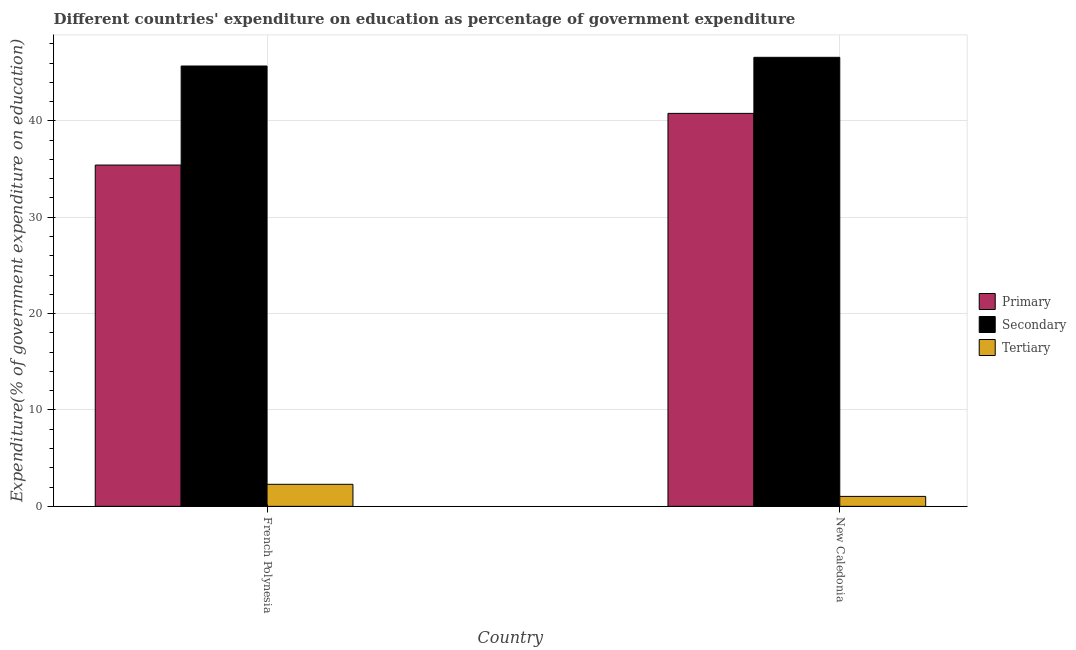How many bars are there on the 2nd tick from the right?
Offer a very short reply. 3. What is the label of the 1st group of bars from the left?
Provide a succinct answer. French Polynesia. In how many cases, is the number of bars for a given country not equal to the number of legend labels?
Make the answer very short. 0. What is the expenditure on secondary education in French Polynesia?
Offer a terse response. 45.69. Across all countries, what is the maximum expenditure on secondary education?
Provide a short and direct response. 46.59. Across all countries, what is the minimum expenditure on tertiary education?
Your answer should be compact. 1.03. In which country was the expenditure on primary education maximum?
Make the answer very short. New Caledonia. In which country was the expenditure on tertiary education minimum?
Your response must be concise. New Caledonia. What is the total expenditure on primary education in the graph?
Make the answer very short. 76.19. What is the difference between the expenditure on tertiary education in French Polynesia and that in New Caledonia?
Your response must be concise. 1.26. What is the difference between the expenditure on primary education in French Polynesia and the expenditure on secondary education in New Caledonia?
Your answer should be very brief. -11.18. What is the average expenditure on tertiary education per country?
Keep it short and to the point. 1.66. What is the difference between the expenditure on secondary education and expenditure on primary education in French Polynesia?
Provide a short and direct response. 10.28. What is the ratio of the expenditure on primary education in French Polynesia to that in New Caledonia?
Keep it short and to the point. 0.87. Is the expenditure on primary education in French Polynesia less than that in New Caledonia?
Keep it short and to the point. Yes. In how many countries, is the expenditure on secondary education greater than the average expenditure on secondary education taken over all countries?
Provide a short and direct response. 1. What does the 1st bar from the left in French Polynesia represents?
Ensure brevity in your answer.  Primary. What does the 1st bar from the right in New Caledonia represents?
Keep it short and to the point. Tertiary. Are all the bars in the graph horizontal?
Your answer should be compact. No. How many countries are there in the graph?
Give a very brief answer. 2. What is the difference between two consecutive major ticks on the Y-axis?
Make the answer very short. 10. Are the values on the major ticks of Y-axis written in scientific E-notation?
Ensure brevity in your answer.  No. Does the graph contain grids?
Provide a short and direct response. Yes. Where does the legend appear in the graph?
Your response must be concise. Center right. What is the title of the graph?
Ensure brevity in your answer.  Different countries' expenditure on education as percentage of government expenditure. Does "Other sectors" appear as one of the legend labels in the graph?
Your answer should be very brief. No. What is the label or title of the Y-axis?
Keep it short and to the point. Expenditure(% of government expenditure on education). What is the Expenditure(% of government expenditure on education) of Primary in French Polynesia?
Provide a short and direct response. 35.41. What is the Expenditure(% of government expenditure on education) of Secondary in French Polynesia?
Your response must be concise. 45.69. What is the Expenditure(% of government expenditure on education) of Tertiary in French Polynesia?
Provide a succinct answer. 2.29. What is the Expenditure(% of government expenditure on education) in Primary in New Caledonia?
Provide a short and direct response. 40.77. What is the Expenditure(% of government expenditure on education) in Secondary in New Caledonia?
Your answer should be very brief. 46.59. What is the Expenditure(% of government expenditure on education) in Tertiary in New Caledonia?
Offer a terse response. 1.03. Across all countries, what is the maximum Expenditure(% of government expenditure on education) in Primary?
Provide a succinct answer. 40.77. Across all countries, what is the maximum Expenditure(% of government expenditure on education) in Secondary?
Offer a terse response. 46.59. Across all countries, what is the maximum Expenditure(% of government expenditure on education) of Tertiary?
Keep it short and to the point. 2.29. Across all countries, what is the minimum Expenditure(% of government expenditure on education) in Primary?
Ensure brevity in your answer.  35.41. Across all countries, what is the minimum Expenditure(% of government expenditure on education) of Secondary?
Offer a terse response. 45.69. Across all countries, what is the minimum Expenditure(% of government expenditure on education) in Tertiary?
Make the answer very short. 1.03. What is the total Expenditure(% of government expenditure on education) of Primary in the graph?
Provide a short and direct response. 76.19. What is the total Expenditure(% of government expenditure on education) of Secondary in the graph?
Your answer should be very brief. 92.28. What is the total Expenditure(% of government expenditure on education) of Tertiary in the graph?
Provide a short and direct response. 3.32. What is the difference between the Expenditure(% of government expenditure on education) in Primary in French Polynesia and that in New Caledonia?
Ensure brevity in your answer.  -5.36. What is the difference between the Expenditure(% of government expenditure on education) of Secondary in French Polynesia and that in New Caledonia?
Give a very brief answer. -0.9. What is the difference between the Expenditure(% of government expenditure on education) of Tertiary in French Polynesia and that in New Caledonia?
Make the answer very short. 1.26. What is the difference between the Expenditure(% of government expenditure on education) in Primary in French Polynesia and the Expenditure(% of government expenditure on education) in Secondary in New Caledonia?
Make the answer very short. -11.18. What is the difference between the Expenditure(% of government expenditure on education) in Primary in French Polynesia and the Expenditure(% of government expenditure on education) in Tertiary in New Caledonia?
Make the answer very short. 34.38. What is the difference between the Expenditure(% of government expenditure on education) in Secondary in French Polynesia and the Expenditure(% of government expenditure on education) in Tertiary in New Caledonia?
Ensure brevity in your answer.  44.66. What is the average Expenditure(% of government expenditure on education) in Primary per country?
Keep it short and to the point. 38.09. What is the average Expenditure(% of government expenditure on education) in Secondary per country?
Offer a terse response. 46.14. What is the average Expenditure(% of government expenditure on education) of Tertiary per country?
Offer a very short reply. 1.66. What is the difference between the Expenditure(% of government expenditure on education) of Primary and Expenditure(% of government expenditure on education) of Secondary in French Polynesia?
Ensure brevity in your answer.  -10.28. What is the difference between the Expenditure(% of government expenditure on education) in Primary and Expenditure(% of government expenditure on education) in Tertiary in French Polynesia?
Provide a succinct answer. 33.13. What is the difference between the Expenditure(% of government expenditure on education) in Secondary and Expenditure(% of government expenditure on education) in Tertiary in French Polynesia?
Give a very brief answer. 43.4. What is the difference between the Expenditure(% of government expenditure on education) in Primary and Expenditure(% of government expenditure on education) in Secondary in New Caledonia?
Your response must be concise. -5.82. What is the difference between the Expenditure(% of government expenditure on education) in Primary and Expenditure(% of government expenditure on education) in Tertiary in New Caledonia?
Your answer should be compact. 39.74. What is the difference between the Expenditure(% of government expenditure on education) in Secondary and Expenditure(% of government expenditure on education) in Tertiary in New Caledonia?
Give a very brief answer. 45.56. What is the ratio of the Expenditure(% of government expenditure on education) of Primary in French Polynesia to that in New Caledonia?
Your answer should be compact. 0.87. What is the ratio of the Expenditure(% of government expenditure on education) of Secondary in French Polynesia to that in New Caledonia?
Your response must be concise. 0.98. What is the ratio of the Expenditure(% of government expenditure on education) in Tertiary in French Polynesia to that in New Caledonia?
Provide a succinct answer. 2.22. What is the difference between the highest and the second highest Expenditure(% of government expenditure on education) in Primary?
Give a very brief answer. 5.36. What is the difference between the highest and the second highest Expenditure(% of government expenditure on education) of Secondary?
Provide a short and direct response. 0.9. What is the difference between the highest and the second highest Expenditure(% of government expenditure on education) in Tertiary?
Give a very brief answer. 1.26. What is the difference between the highest and the lowest Expenditure(% of government expenditure on education) in Primary?
Your answer should be compact. 5.36. What is the difference between the highest and the lowest Expenditure(% of government expenditure on education) in Secondary?
Offer a terse response. 0.9. What is the difference between the highest and the lowest Expenditure(% of government expenditure on education) of Tertiary?
Provide a short and direct response. 1.26. 